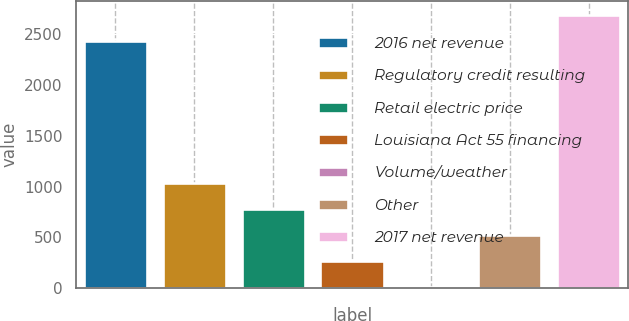Convert chart. <chart><loc_0><loc_0><loc_500><loc_500><bar_chart><fcel>2016 net revenue<fcel>Regulatory credit resulting<fcel>Retail electric price<fcel>Louisiana Act 55 financing<fcel>Volume/weather<fcel>Other<fcel>2017 net revenue<nl><fcel>2438.4<fcel>1031.64<fcel>776.83<fcel>267.21<fcel>12.4<fcel>522.02<fcel>2693.21<nl></chart> 